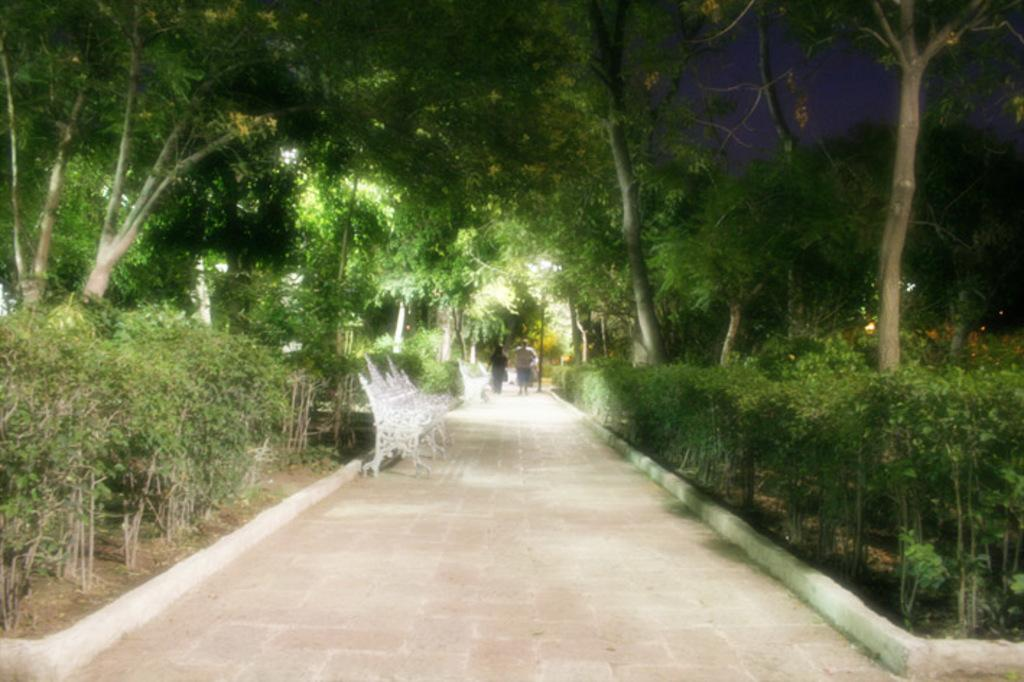What type of location is depicted in the image? There is a park in the image. What kind of seating is available in the park? There is a bench in the park. What natural elements can be seen in the park? There are plants and trees in the park. What are the two persons in the image doing? Two persons are walking in the park. What is visible in the background of the image? The sky is visible in the image. What type of line can be seen connecting the sky and the pail in the image? There is no pail or line connecting the sky and any object in the image. The image only features a park with a bench, plants, trees, and two persons walking. 